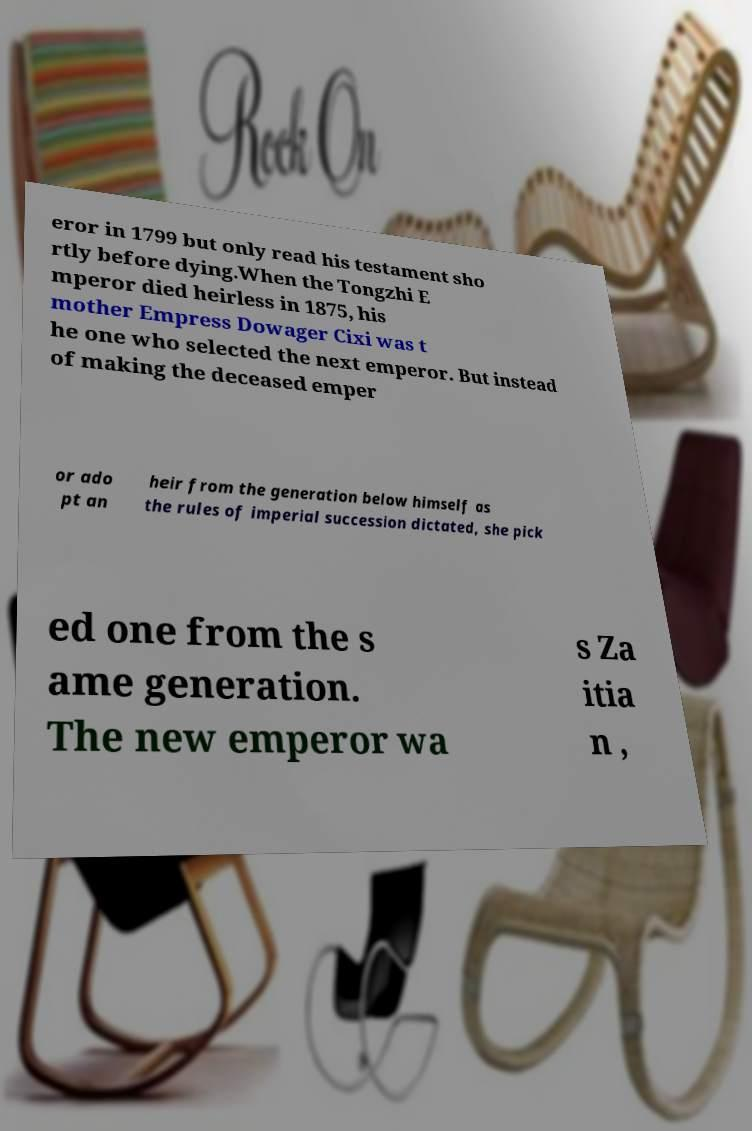Could you extract and type out the text from this image? eror in 1799 but only read his testament sho rtly before dying.When the Tongzhi E mperor died heirless in 1875, his mother Empress Dowager Cixi was t he one who selected the next emperor. But instead of making the deceased emper or ado pt an heir from the generation below himself as the rules of imperial succession dictated, she pick ed one from the s ame generation. The new emperor wa s Za itia n , 